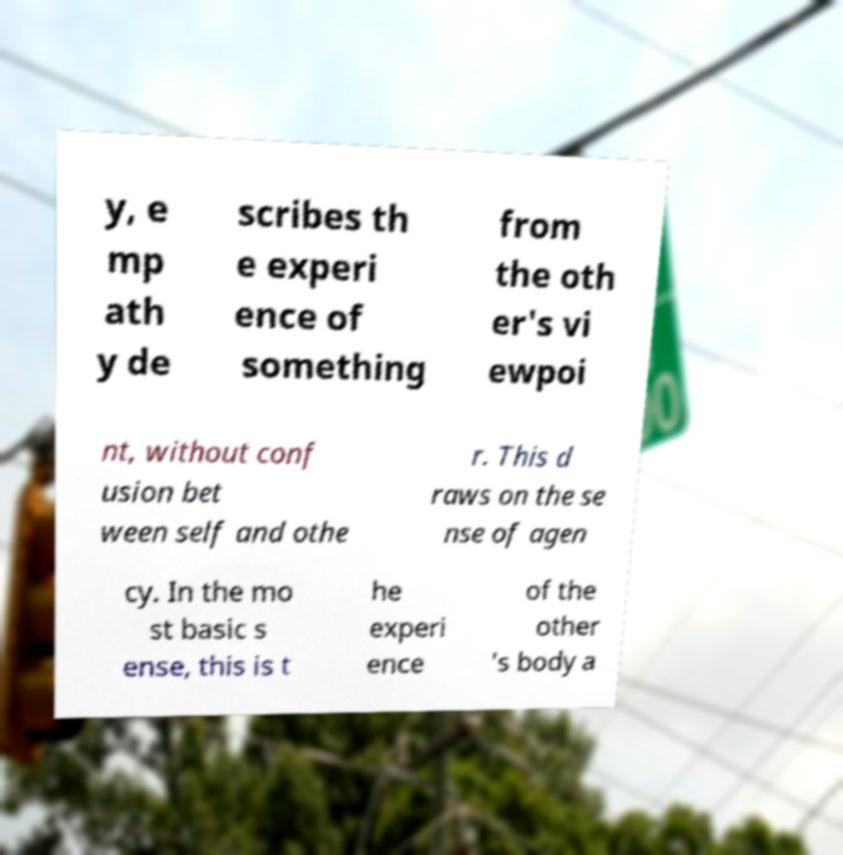What messages or text are displayed in this image? I need them in a readable, typed format. y, e mp ath y de scribes th e experi ence of something from the oth er's vi ewpoi nt, without conf usion bet ween self and othe r. This d raws on the se nse of agen cy. In the mo st basic s ense, this is t he experi ence of the other 's body a 